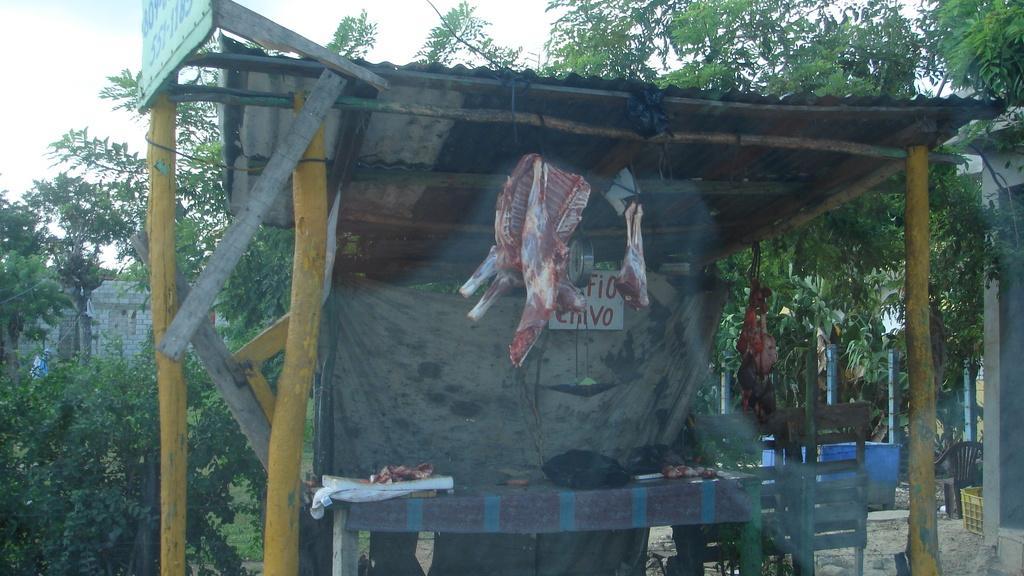Can you describe this image briefly? In the image we can see a meat shop. Behind the meat shop there are some trees and buildings and poles. 